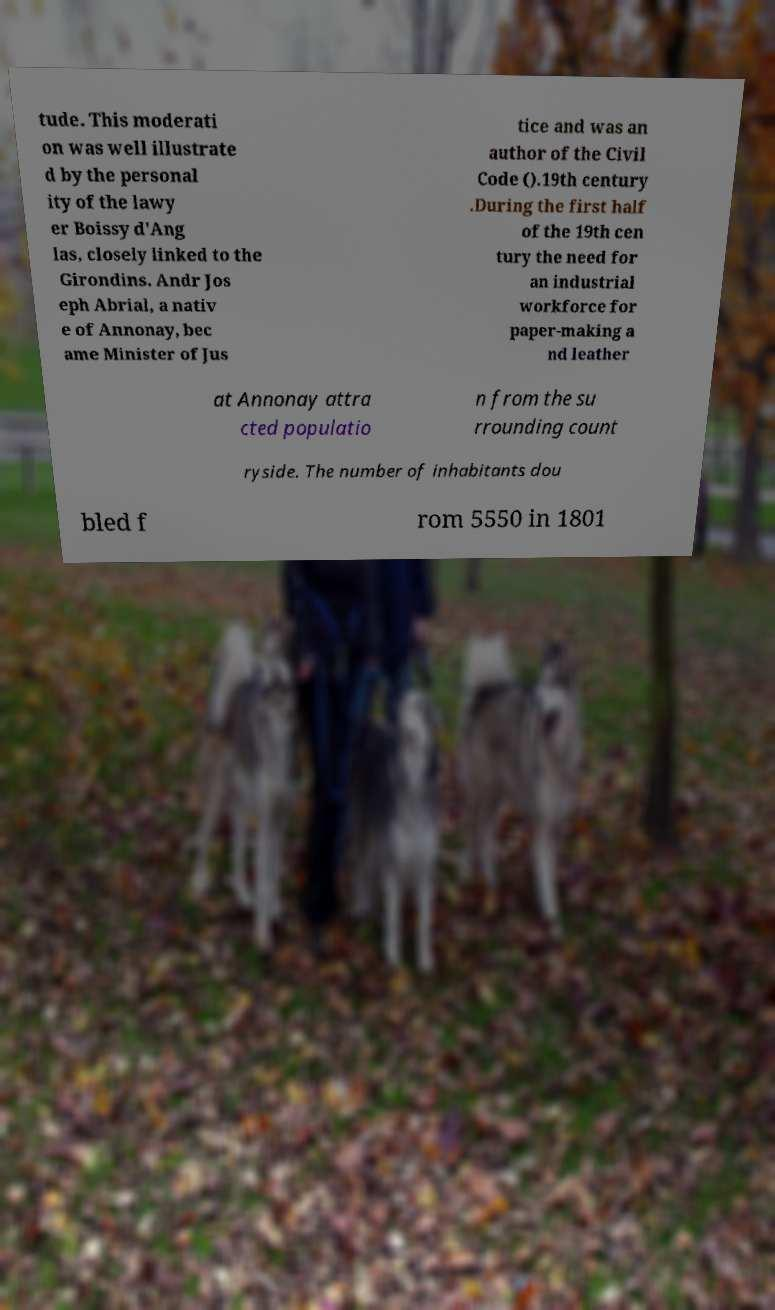I need the written content from this picture converted into text. Can you do that? tude. This moderati on was well illustrate d by the personal ity of the lawy er Boissy d'Ang las, closely linked to the Girondins. Andr Jos eph Abrial, a nativ e of Annonay, bec ame Minister of Jus tice and was an author of the Civil Code ().19th century .During the first half of the 19th cen tury the need for an industrial workforce for paper-making a nd leather at Annonay attra cted populatio n from the su rrounding count ryside. The number of inhabitants dou bled f rom 5550 in 1801 